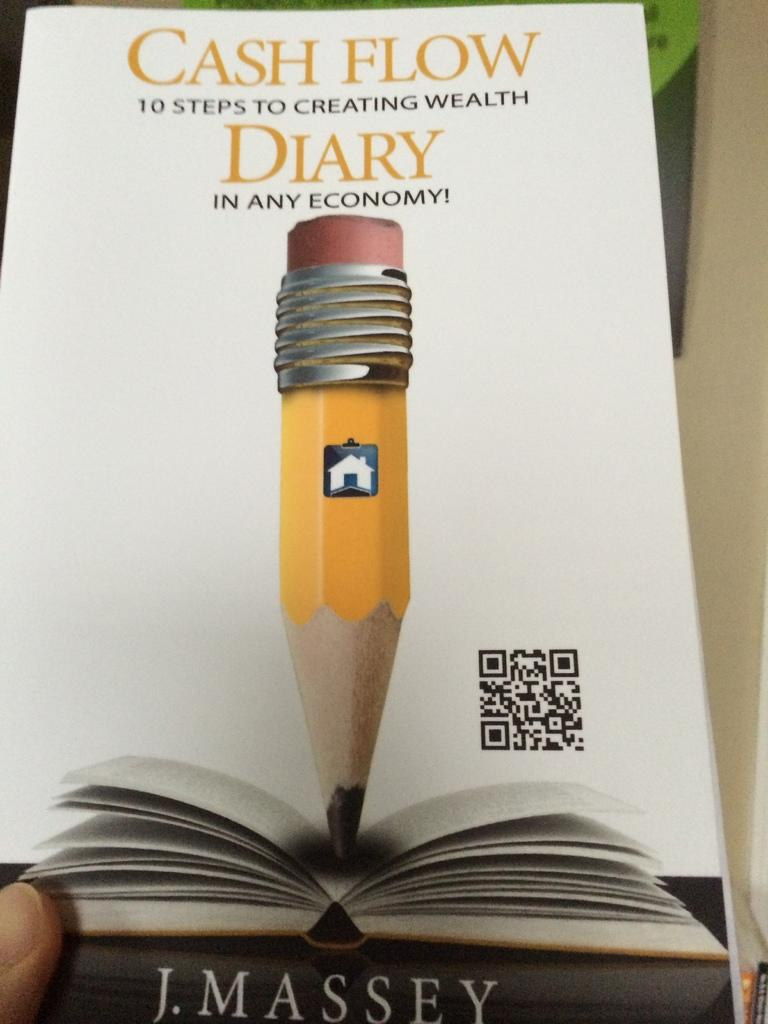Provide a one-sentence caption for the provided image. J. Massey has written a book about 10 steps to creating wealth. 